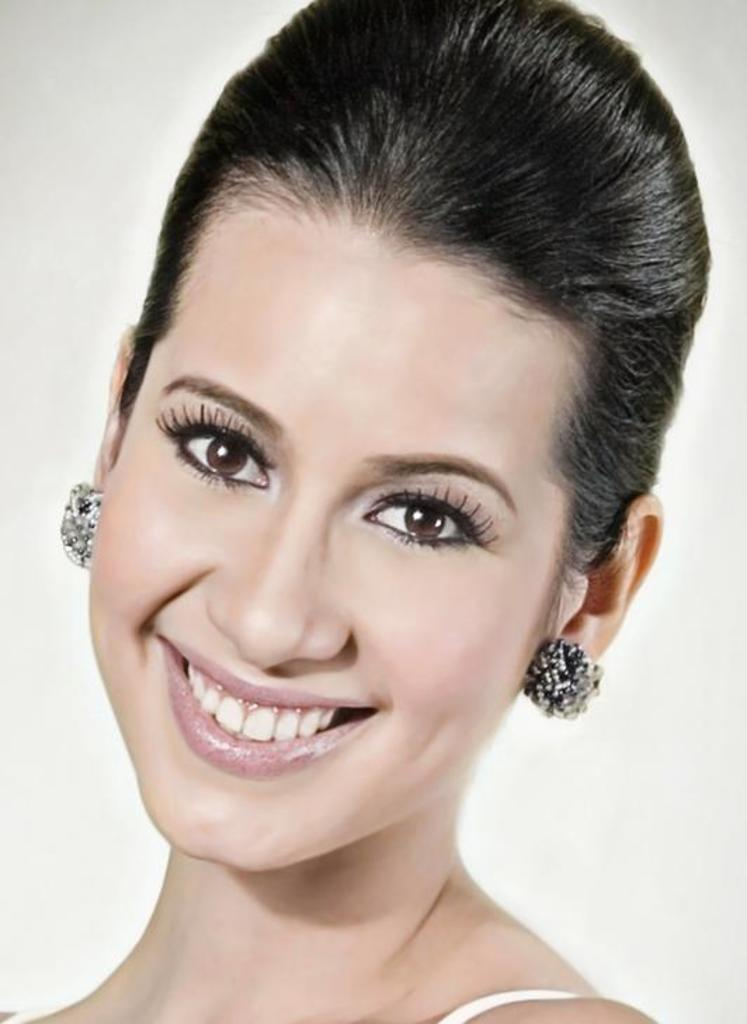Who is present in the image? There is a woman in the image. What is the woman's facial expression? The woman is smiling. What is the color of the background in the image? The background in the image is white. What does the woman hate in the image? There is no information about the woman's likes or dislikes in the image, so it cannot be determined what she might hate. 